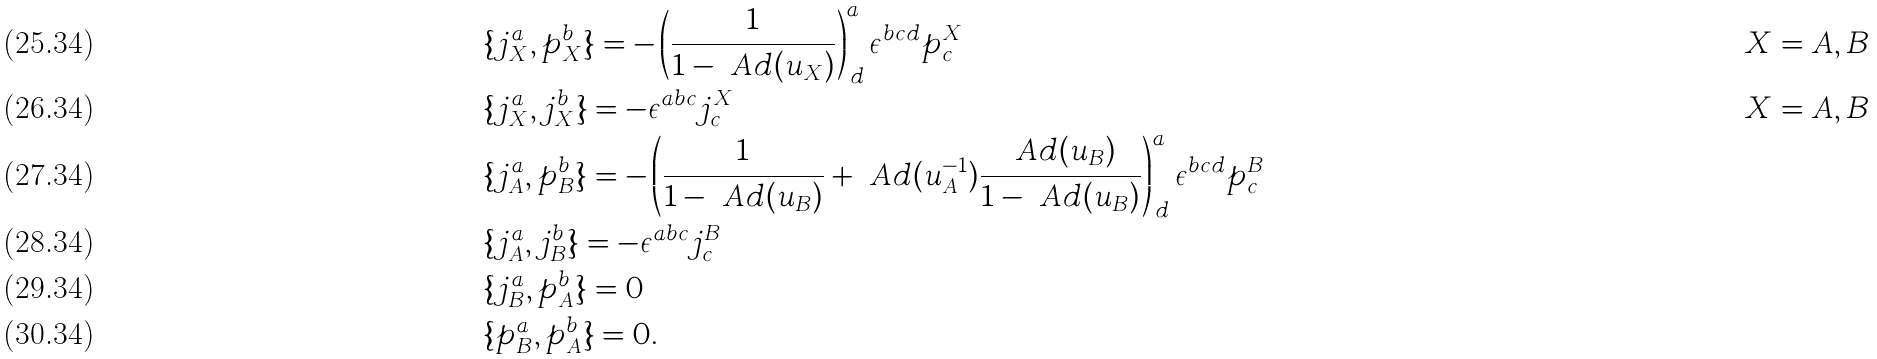Convert formula to latex. <formula><loc_0><loc_0><loc_500><loc_500>& \{ j _ { X } ^ { a } , p _ { X } ^ { b } \} = - \left ( \frac { 1 } { 1 - \ A d ( { u _ { X } } ) } \right ) ^ { a } _ { \, d } \epsilon ^ { b c d } p _ { c } ^ { X } & & X = A , B \\ & \{ j _ { X } ^ { a } , j _ { X } ^ { b } \} = - \epsilon ^ { a b c } j _ { c } ^ { X } & & X = A , B \\ & \{ j _ { A } ^ { a } , p _ { B } ^ { b } \} = - \left ( \frac { 1 } { 1 - \ A d ( { u _ { B } } ) } + \ A d ( { u ^ { - 1 } _ { A } } ) \frac { \ A d ( { u _ { B } } ) } { 1 - \ A d ( { u _ { B } } ) } \right ) ^ { a } _ { \, d } \epsilon ^ { b c d } p _ { c } ^ { B } \\ & \{ j _ { A } ^ { a } , j _ { B } ^ { b } \} = - \epsilon ^ { a b c } j _ { c } ^ { B } \\ & \{ j _ { B } ^ { a } , p _ { A } ^ { b } \} = 0 \\ & \{ p _ { B } ^ { a } , p _ { A } ^ { b } \} = 0 .</formula> 